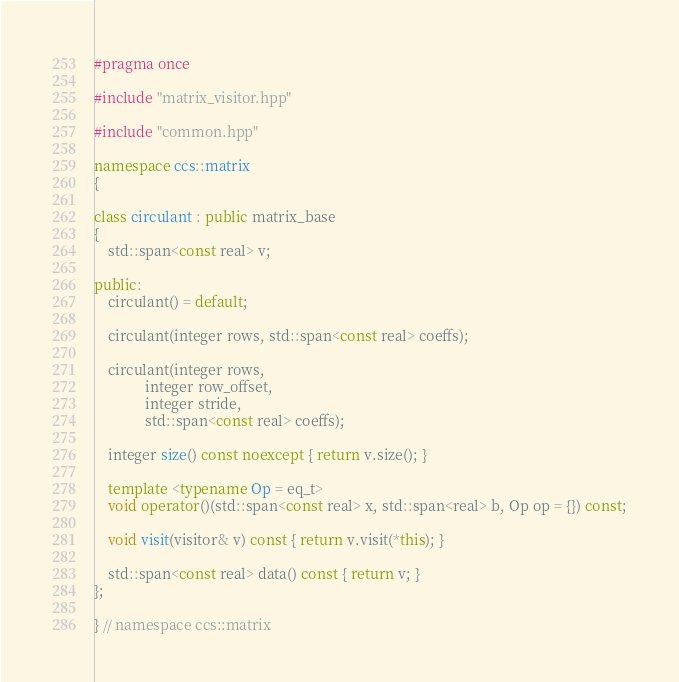Convert code to text. <code><loc_0><loc_0><loc_500><loc_500><_C++_>#pragma once

#include "matrix_visitor.hpp"

#include "common.hpp"

namespace ccs::matrix
{

class circulant : public matrix_base
{
    std::span<const real> v;

public:
    circulant() = default;

    circulant(integer rows, std::span<const real> coeffs);

    circulant(integer rows,
              integer row_offset,
              integer stride,
              std::span<const real> coeffs);

    integer size() const noexcept { return v.size(); }

    template <typename Op = eq_t>
    void operator()(std::span<const real> x, std::span<real> b, Op op = {}) const;

    void visit(visitor& v) const { return v.visit(*this); }

    std::span<const real> data() const { return v; }
};

} // namespace ccs::matrix
</code> 